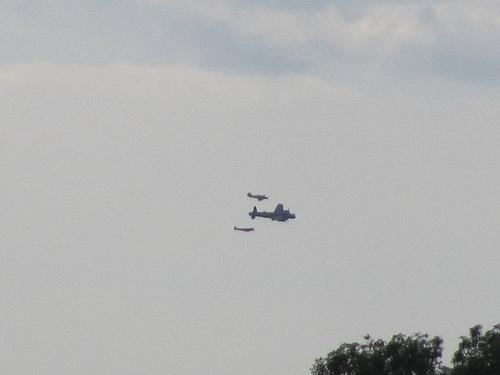Discuss the main focus of the image and the purpose behind the scene. The main focus of the image is three airplanes flying in formation, possibly participating in an airshow. The purpose is to showcase classic warplanes and their performance abilities. Describe the sky background and its impact on the overall image sentiment. The sky background features grey clouds with some blue patches, giving the image an overcast feeling, indicating a somber or gloomy sentiment. How many airplanes are in the image and what are their characteristics? There are three airplanes; the largest one has two tailwings and propellers on the wings, flanked by two smaller planes, one on the left and one on the right. All planes are grey and have propellers. Determine the weather conditions based on the sky and cloud patterns in the image. The weather conditions are overcast and gloomy, with dark grey clouds covering most of the sky, making it a cloudy day. What are the primary objects in the image and their color? The primary objects are three gray airplanes flying in formation, green-leaved trees below them, and grey clouds with blue patches in the sky. Identify and provide a count of the tree-related elements in the image. There are dark trees with green leaves below the airplanes, and the gap between them; there are at least two tree-related elements in the image. List the main visual elements in the image and describe the overall atmosphere. Main elements include three airplanes flying in formation, trees with green leaves below the planes, and grey clouds with blue patches. The overall atmosphere is overcast and grey. Analyze the positions and sizes of the planes, and how they are interacting with each other. The largest plane is in the center, flanked by two smaller planes on either side. They are flying in formation, with the smaller planes following the larger one, indicating a coordinated performance. Give a brief description of the main action happening in the image. Three classic warplanes, one large flanked by two smaller, are performing a flyover during an airshow on a cloudy day. What kind of event could be taking place in this image involving the airplanes? The event could be an airshow where the three classic warplanes, one large and two smaller, perform a flyover or coordinated aerial demonstration. Do the trees have red and orange leaves, indicating autumn season? No, it's not mentioned in the image. 